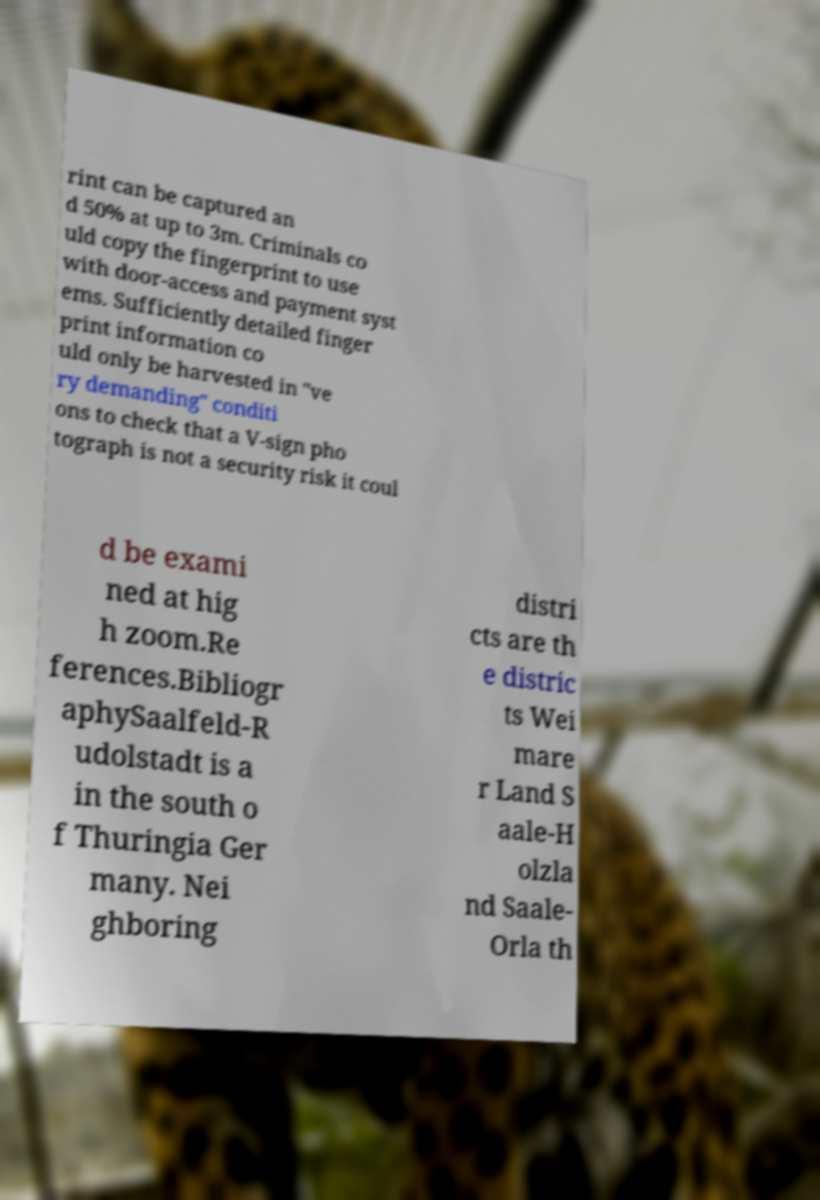Please identify and transcribe the text found in this image. rint can be captured an d 50% at up to 3m. Criminals co uld copy the fingerprint to use with door-access and payment syst ems. Sufficiently detailed finger print information co uld only be harvested in "ve ry demanding" conditi ons to check that a V-sign pho tograph is not a security risk it coul d be exami ned at hig h zoom.Re ferences.Bibliogr aphySaalfeld-R udolstadt is a in the south o f Thuringia Ger many. Nei ghboring distri cts are th e distric ts Wei mare r Land S aale-H olzla nd Saale- Orla th 